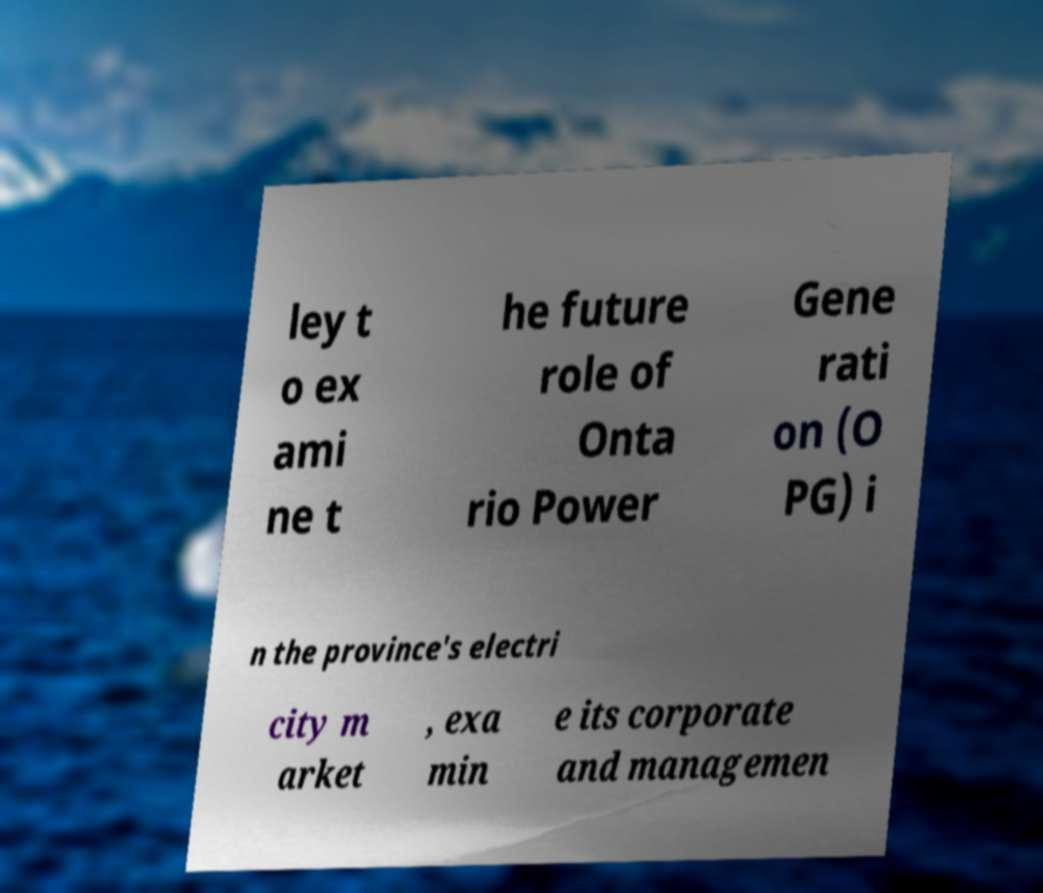What messages or text are displayed in this image? I need them in a readable, typed format. ley t o ex ami ne t he future role of Onta rio Power Gene rati on (O PG) i n the province's electri city m arket , exa min e its corporate and managemen 